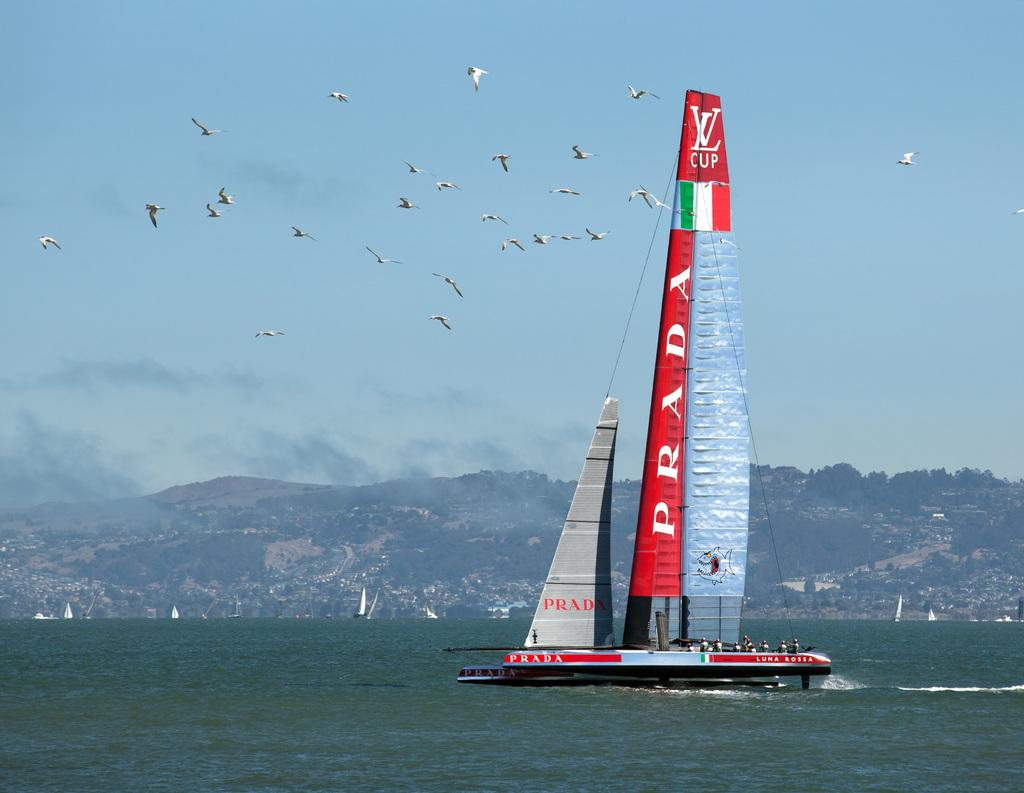<image>
Render a clear and concise summary of the photo. A sailboat has a red sail that says PRADA on it 